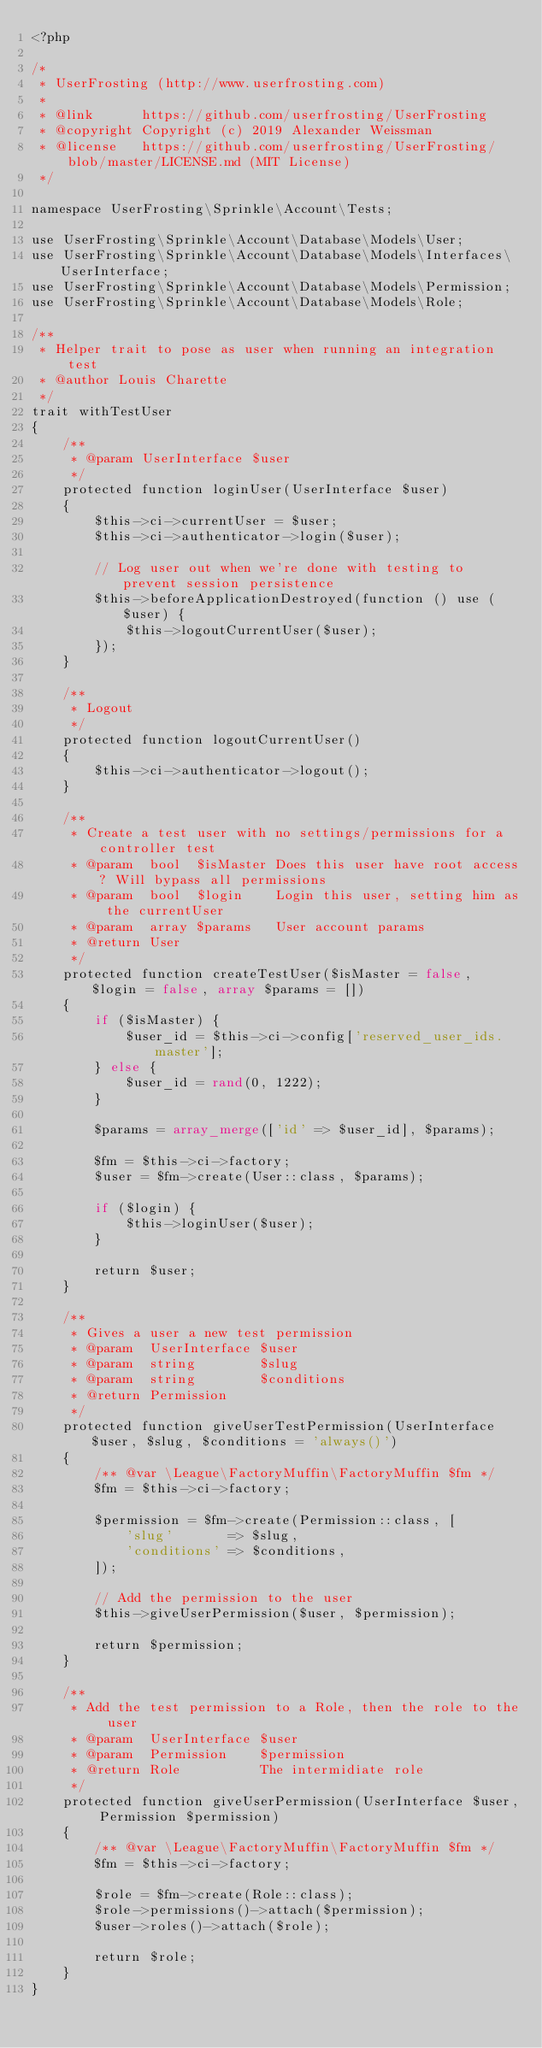<code> <loc_0><loc_0><loc_500><loc_500><_PHP_><?php

/*
 * UserFrosting (http://www.userfrosting.com)
 *
 * @link      https://github.com/userfrosting/UserFrosting
 * @copyright Copyright (c) 2019 Alexander Weissman
 * @license   https://github.com/userfrosting/UserFrosting/blob/master/LICENSE.md (MIT License)
 */

namespace UserFrosting\Sprinkle\Account\Tests;

use UserFrosting\Sprinkle\Account\Database\Models\User;
use UserFrosting\Sprinkle\Account\Database\Models\Interfaces\UserInterface;
use UserFrosting\Sprinkle\Account\Database\Models\Permission;
use UserFrosting\Sprinkle\Account\Database\Models\Role;

/**
 * Helper trait to pose as user when running an integration test
 * @author Louis Charette
 */
trait withTestUser
{
    /**
     * @param UserInterface $user
     */
    protected function loginUser(UserInterface $user)
    {
        $this->ci->currentUser = $user;
        $this->ci->authenticator->login($user);

        // Log user out when we're done with testing to prevent session persistence
        $this->beforeApplicationDestroyed(function () use ($user) {
            $this->logoutCurrentUser($user);
        });
    }

    /**
     * Logout
     */
    protected function logoutCurrentUser()
    {
        $this->ci->authenticator->logout();
    }

    /**
     * Create a test user with no settings/permissions for a controller test
     * @param  bool  $isMaster Does this user have root access? Will bypass all permissions
     * @param  bool  $login    Login this user, setting him as the currentUser
     * @param  array $params   User account params
     * @return User
     */
    protected function createTestUser($isMaster = false, $login = false, array $params = [])
    {
        if ($isMaster) {
            $user_id = $this->ci->config['reserved_user_ids.master'];
        } else {
            $user_id = rand(0, 1222);
        }

        $params = array_merge(['id' => $user_id], $params);

        $fm = $this->ci->factory;
        $user = $fm->create(User::class, $params);

        if ($login) {
            $this->loginUser($user);
        }

        return $user;
    }

    /**
     * Gives a user a new test permission
     * @param  UserInterface $user
     * @param  string        $slug
     * @param  string        $conditions
     * @return Permission
     */
    protected function giveUserTestPermission(UserInterface $user, $slug, $conditions = 'always()')
    {
        /** @var \League\FactoryMuffin\FactoryMuffin $fm */
        $fm = $this->ci->factory;

        $permission = $fm->create(Permission::class, [
            'slug'       => $slug,
            'conditions' => $conditions,
        ]);

        // Add the permission to the user
        $this->giveUserPermission($user, $permission);

        return $permission;
    }

    /**
     * Add the test permission to a Role, then the role to the user
     * @param  UserInterface $user
     * @param  Permission    $permission
     * @return Role          The intermidiate role
     */
    protected function giveUserPermission(UserInterface $user, Permission $permission)
    {
        /** @var \League\FactoryMuffin\FactoryMuffin $fm */
        $fm = $this->ci->factory;

        $role = $fm->create(Role::class);
        $role->permissions()->attach($permission);
        $user->roles()->attach($role);

        return $role;
    }
}
</code> 